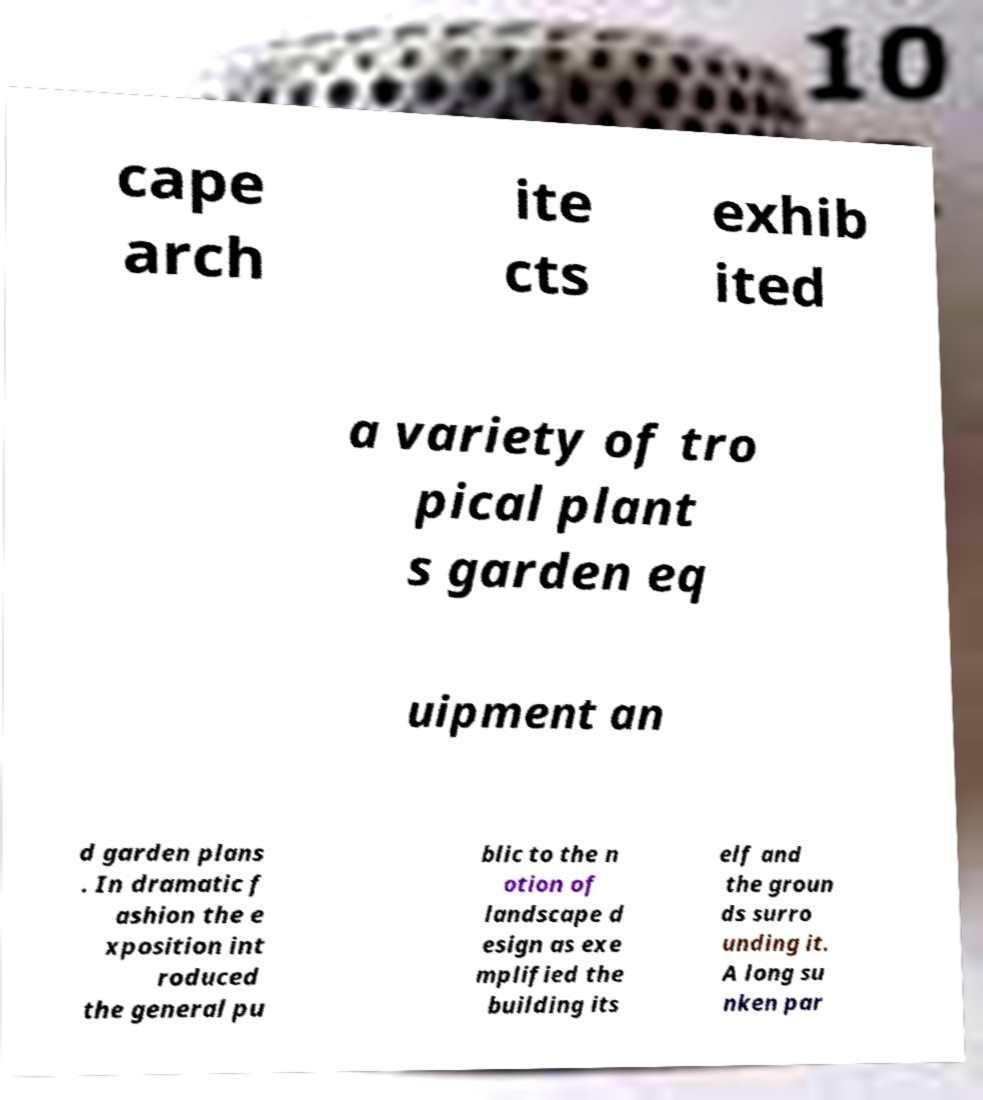Can you read and provide the text displayed in the image?This photo seems to have some interesting text. Can you extract and type it out for me? cape arch ite cts exhib ited a variety of tro pical plant s garden eq uipment an d garden plans . In dramatic f ashion the e xposition int roduced the general pu blic to the n otion of landscape d esign as exe mplified the building its elf and the groun ds surro unding it. A long su nken par 